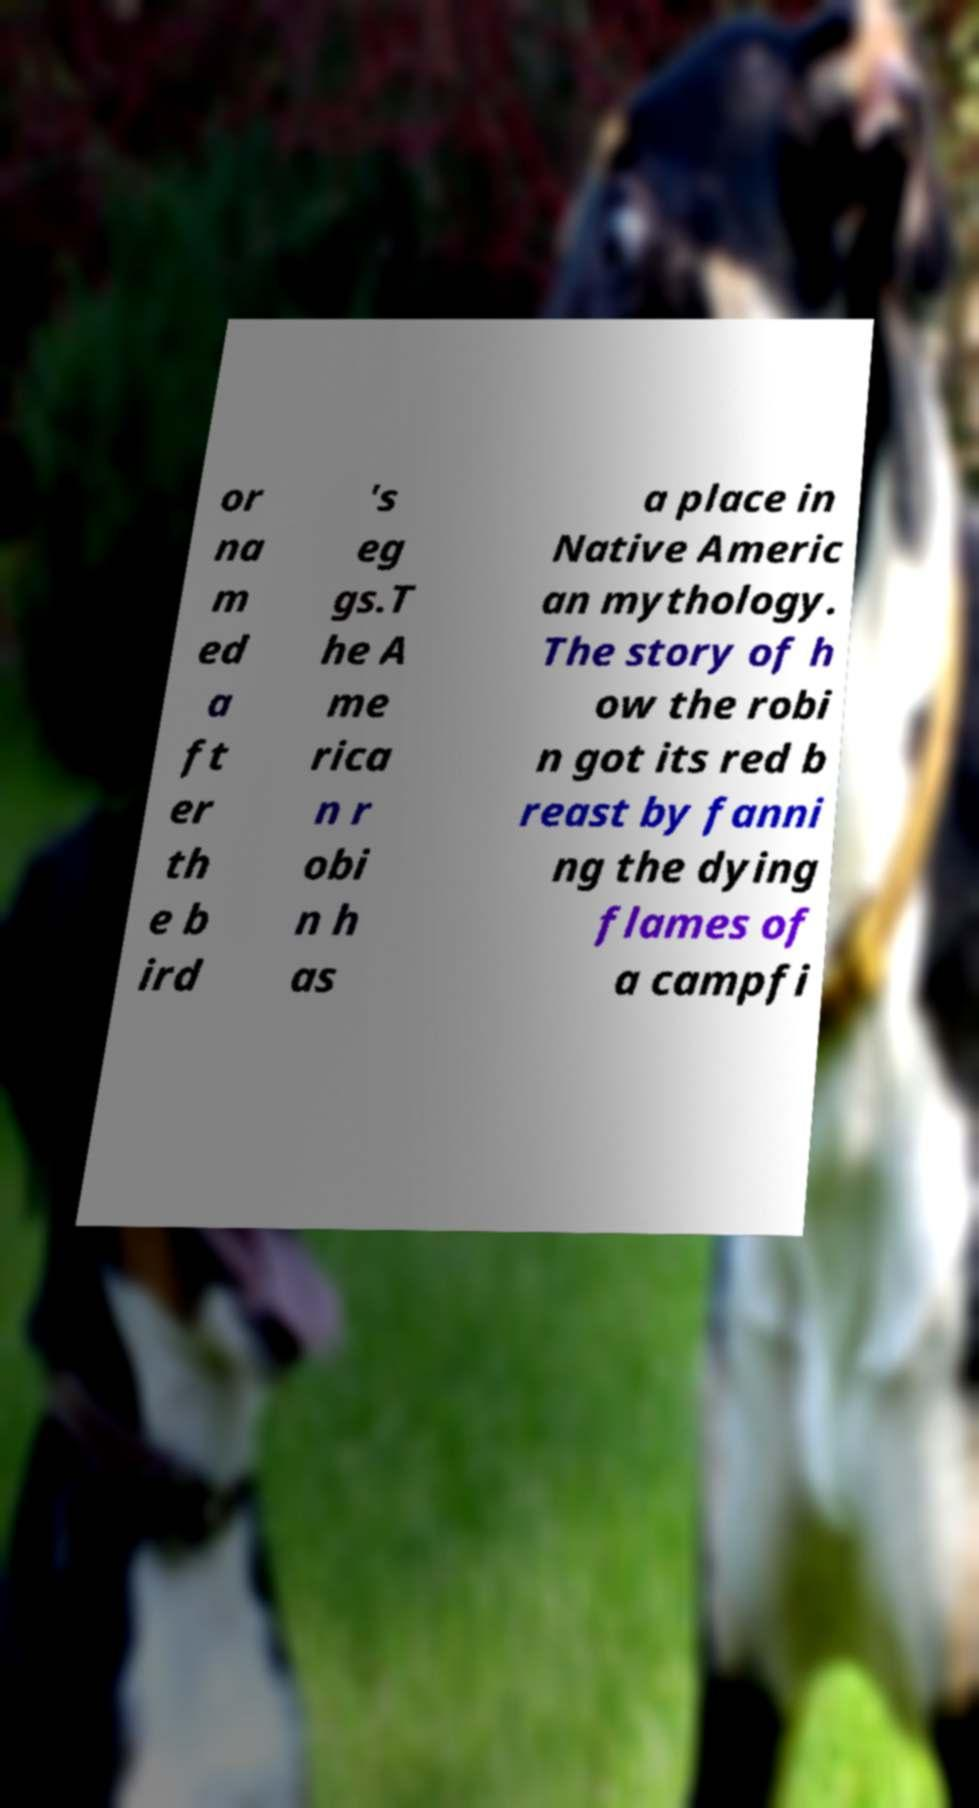Can you read and provide the text displayed in the image?This photo seems to have some interesting text. Can you extract and type it out for me? or na m ed a ft er th e b ird 's eg gs.T he A me rica n r obi n h as a place in Native Americ an mythology. The story of h ow the robi n got its red b reast by fanni ng the dying flames of a campfi 